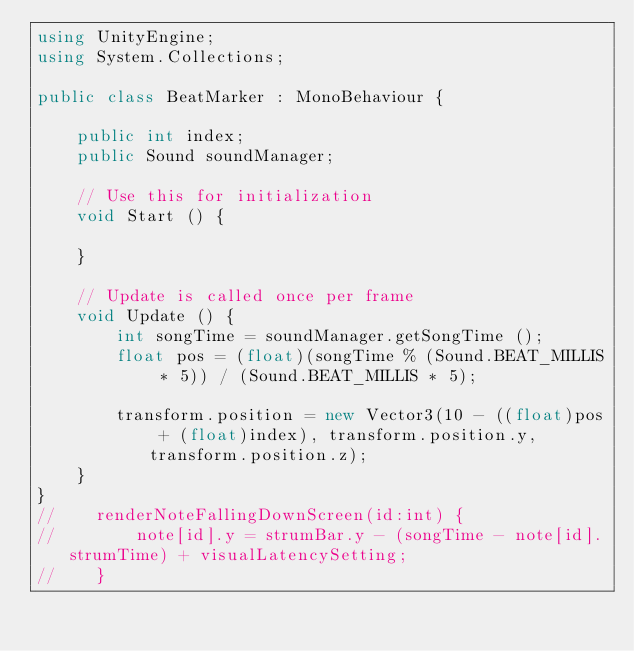Convert code to text. <code><loc_0><loc_0><loc_500><loc_500><_C#_>using UnityEngine;
using System.Collections;

public class BeatMarker : MonoBehaviour {

	public int index;
	public Sound soundManager;

	// Use this for initialization
	void Start () {
	
	}
	
	// Update is called once per frame
	void Update () {
		int songTime = soundManager.getSongTime ();
		float pos = (float)(songTime % (Sound.BEAT_MILLIS * 5)) / (Sound.BEAT_MILLIS * 5);

		transform.position = new Vector3(10 - ((float)pos + (float)index), transform.position.y, transform.position.z);
	}
}
//    renderNoteFallingDownScreen(id:int) {
//	      note[id].y = strumBar.y - (songTime - note[id].strumTime) + visualLatencySetting;
//    }</code> 